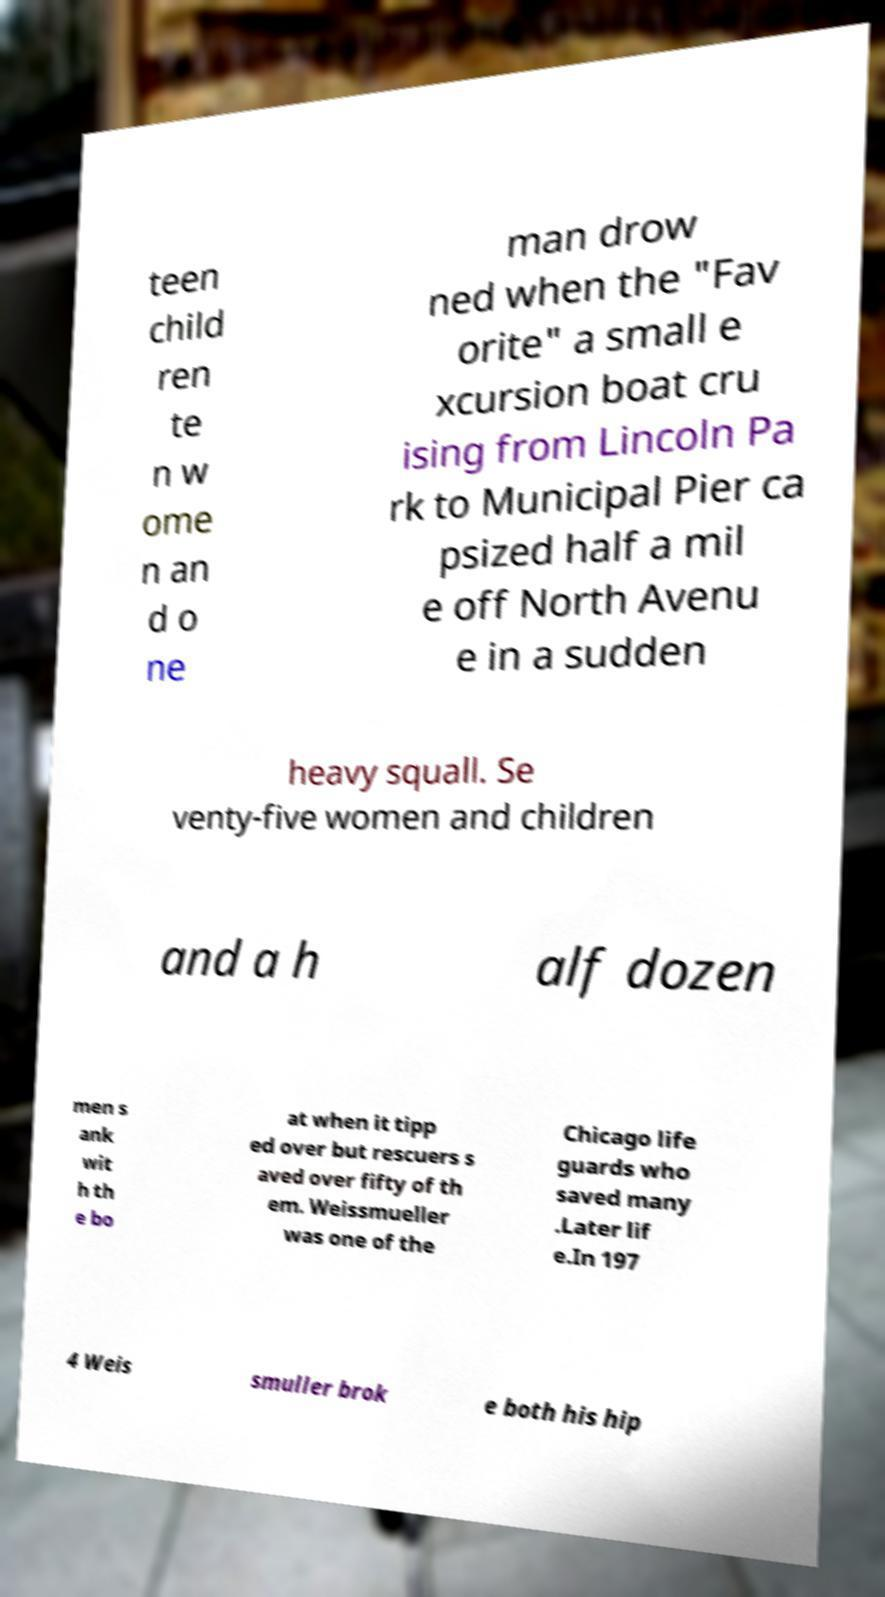Could you assist in decoding the text presented in this image and type it out clearly? teen child ren te n w ome n an d o ne man drow ned when the "Fav orite" a small e xcursion boat cru ising from Lincoln Pa rk to Municipal Pier ca psized half a mil e off North Avenu e in a sudden heavy squall. Se venty-five women and children and a h alf dozen men s ank wit h th e bo at when it tipp ed over but rescuers s aved over fifty of th em. Weissmueller was one of the Chicago life guards who saved many .Later lif e.In 197 4 Weis smuller brok e both his hip 